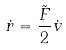<formula> <loc_0><loc_0><loc_500><loc_500>\dot { r } = \frac { \tilde { F } } { 2 } \dot { v }</formula> 